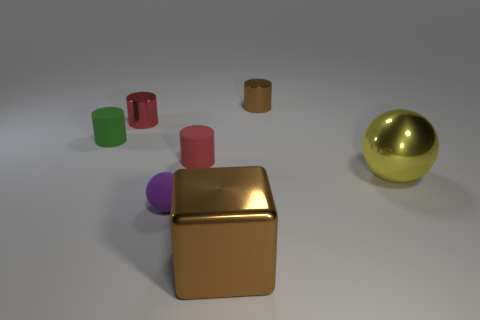What number of other objects are the same size as the brown shiny block?
Your answer should be compact. 1. The brown shiny object that is right of the brown object that is in front of the shiny cylinder that is on the left side of the brown shiny cylinder is what shape?
Your answer should be very brief. Cylinder. What number of green objects are shiny cubes or small spheres?
Provide a succinct answer. 0. There is a brown object that is in front of the brown cylinder; how many balls are in front of it?
Keep it short and to the point. 0. Is there anything else that has the same color as the large metal sphere?
Provide a short and direct response. No. What is the shape of the red object that is the same material as the purple thing?
Your response must be concise. Cylinder. Is the small matte sphere the same color as the big metal sphere?
Your answer should be compact. No. Do the big object that is behind the large metal cube and the sphere to the left of the big brown object have the same material?
Give a very brief answer. No. How many objects are small matte cylinders or matte things to the right of the purple object?
Make the answer very short. 2. Are there any other things that have the same material as the small purple sphere?
Make the answer very short. Yes. 